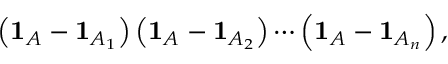<formula> <loc_0><loc_0><loc_500><loc_500>\left ( 1 _ { A } - 1 _ { A _ { 1 } } \right ) \left ( 1 _ { A } - 1 _ { A _ { 2 } } \right ) \cdots \left ( 1 _ { A } - 1 _ { A _ { n } } \right ) ,</formula> 